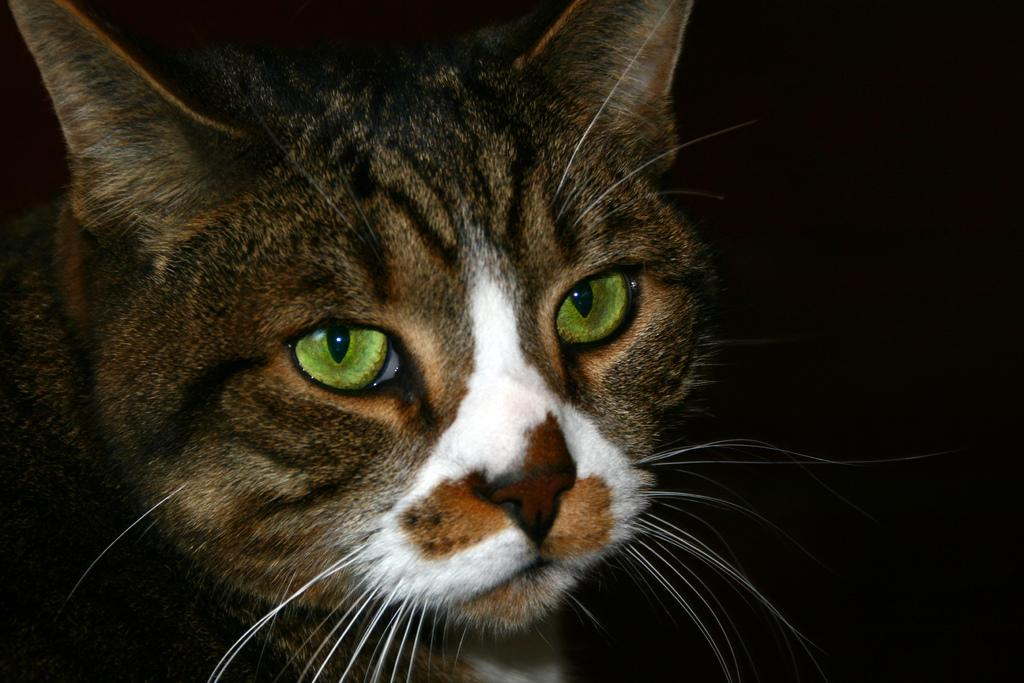What type of animal is in the image? There is a cat in the image. What can be observed about the background of the image? The background of the image is dark. What type of cork can be seen in the image? There is no cork present in the image. What type of line is visible in the image? There is no line visible in the image. Is there a hammer in the image? There is no hammer present in the image. 